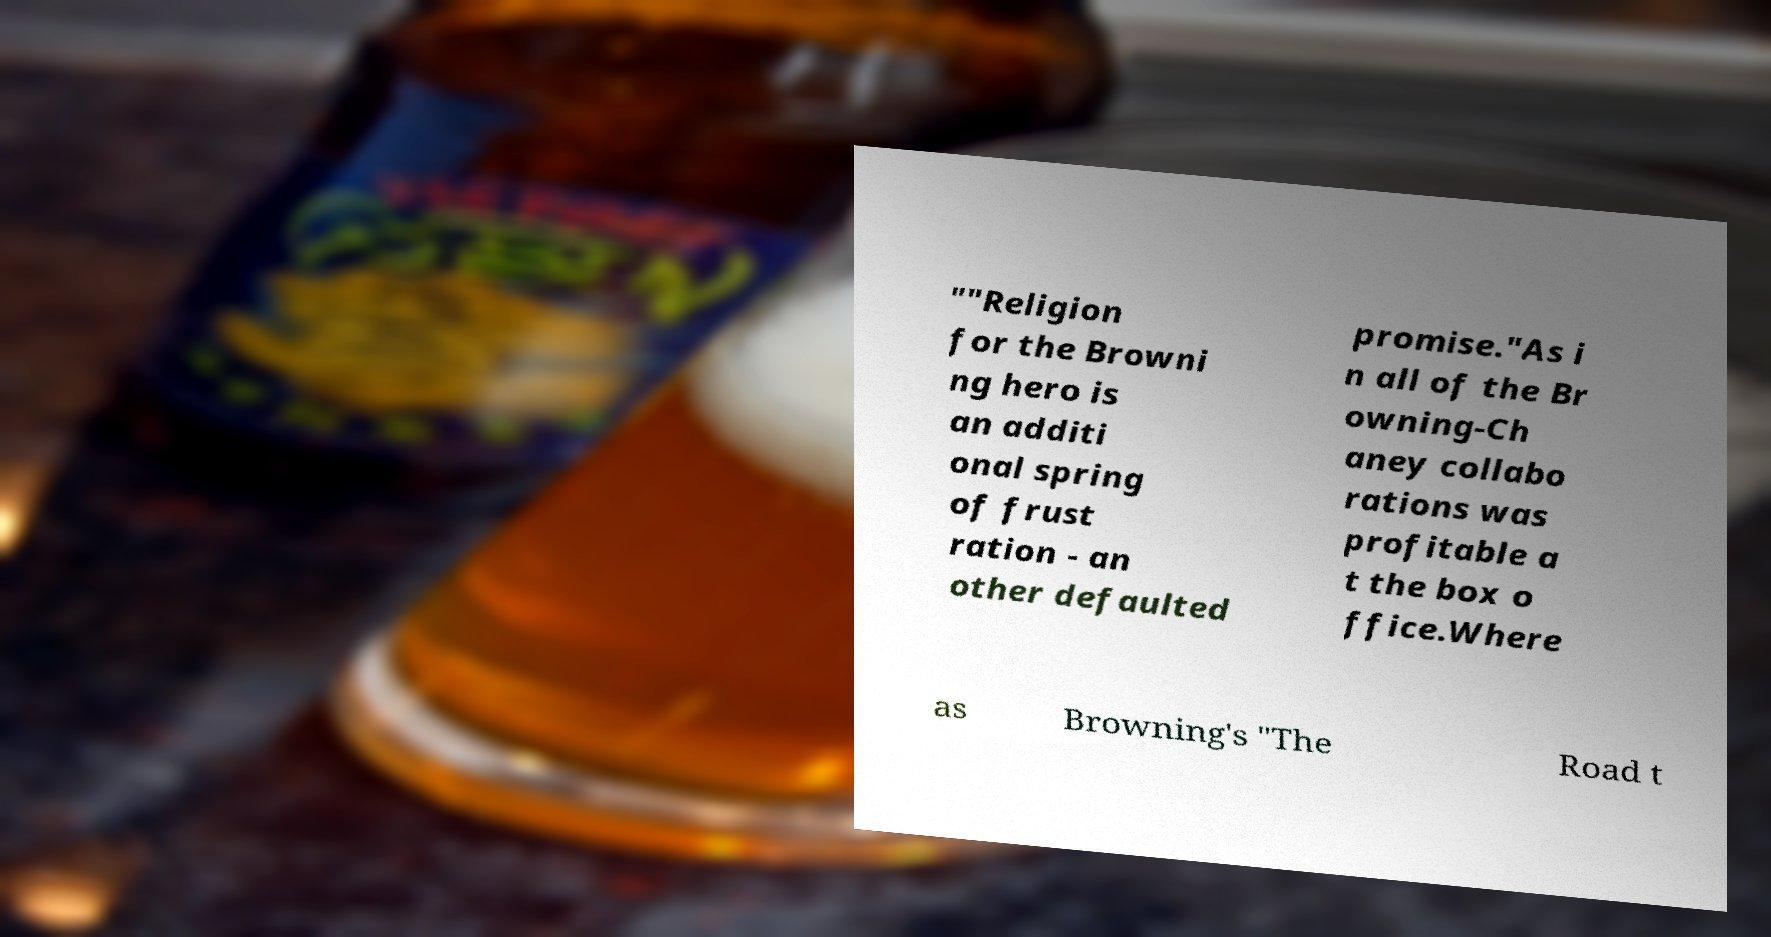Can you read and provide the text displayed in the image?This photo seems to have some interesting text. Can you extract and type it out for me? ""Religion for the Browni ng hero is an additi onal spring of frust ration - an other defaulted promise."As i n all of the Br owning-Ch aney collabo rations was profitable a t the box o ffice.Where as Browning's "The Road t 